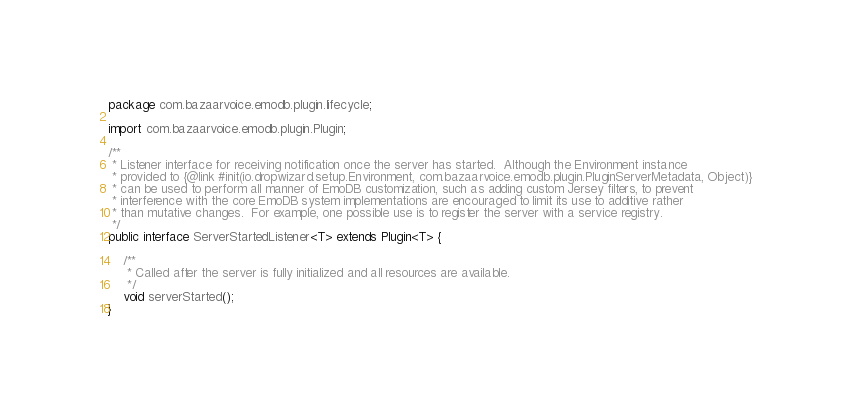Convert code to text. <code><loc_0><loc_0><loc_500><loc_500><_Java_>package com.bazaarvoice.emodb.plugin.lifecycle;

import com.bazaarvoice.emodb.plugin.Plugin;

/**
 * Listener interface for receiving notification once the server has started.  Although the Environment instance
 * provided to {@link #init(io.dropwizard.setup.Environment, com.bazaarvoice.emodb.plugin.PluginServerMetadata, Object)}
 * can be used to perform all manner of EmoDB customization, such as adding custom Jersey filters, to prevent
 * interference with the core EmoDB system implementations are encouraged to limit its use to additive rather
 * than mutative changes.  For example, one possible use is to register the server with a service registry.
 */
public interface ServerStartedListener<T> extends Plugin<T> {

    /**
     * Called after the server is fully initialized and all resources are available.
     */
    void serverStarted();
}
</code> 